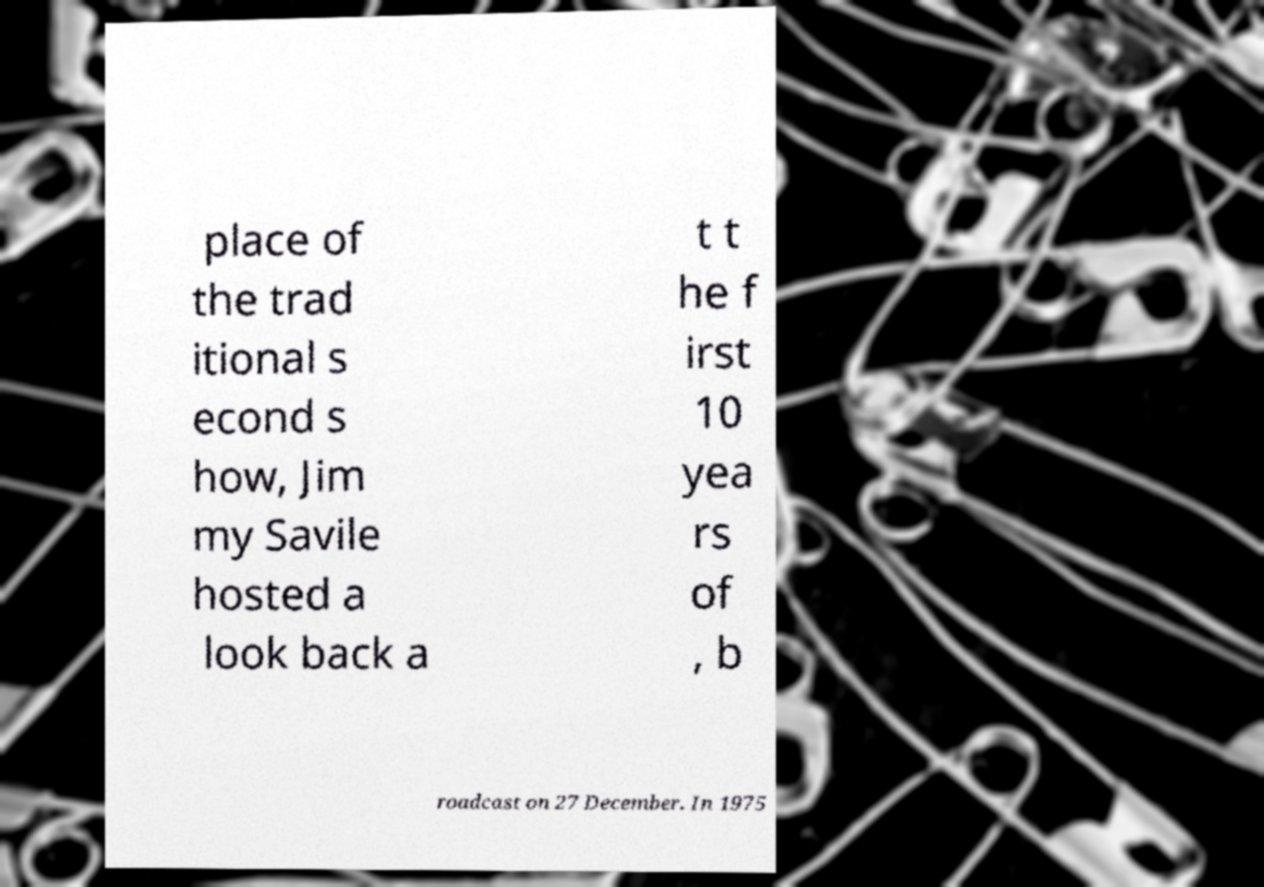Can you accurately transcribe the text from the provided image for me? place of the trad itional s econd s how, Jim my Savile hosted a look back a t t he f irst 10 yea rs of , b roadcast on 27 December. In 1975 